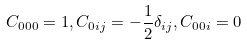<formula> <loc_0><loc_0><loc_500><loc_500>C _ { 0 0 0 } = 1 , C _ { 0 i j } = - \frac { 1 } { 2 } \delta _ { i j } , C _ { 0 0 i } = 0</formula> 